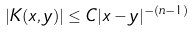Convert formula to latex. <formula><loc_0><loc_0><loc_500><loc_500>| K ( x , y ) | \leq C | x - y | ^ { - ( n - 1 ) }</formula> 